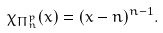Convert formula to latex. <formula><loc_0><loc_0><loc_500><loc_500>\chi _ { \Pi _ { n } ^ { p } } ( x ) = ( x - n ) ^ { n - 1 } .</formula> 